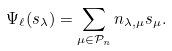Convert formula to latex. <formula><loc_0><loc_0><loc_500><loc_500>\Psi _ { \ell } ( s _ { \lambda } ) = \sum _ { \mu \in \mathcal { P } _ { n } } n _ { \lambda , \mu } s _ { \mu } .</formula> 